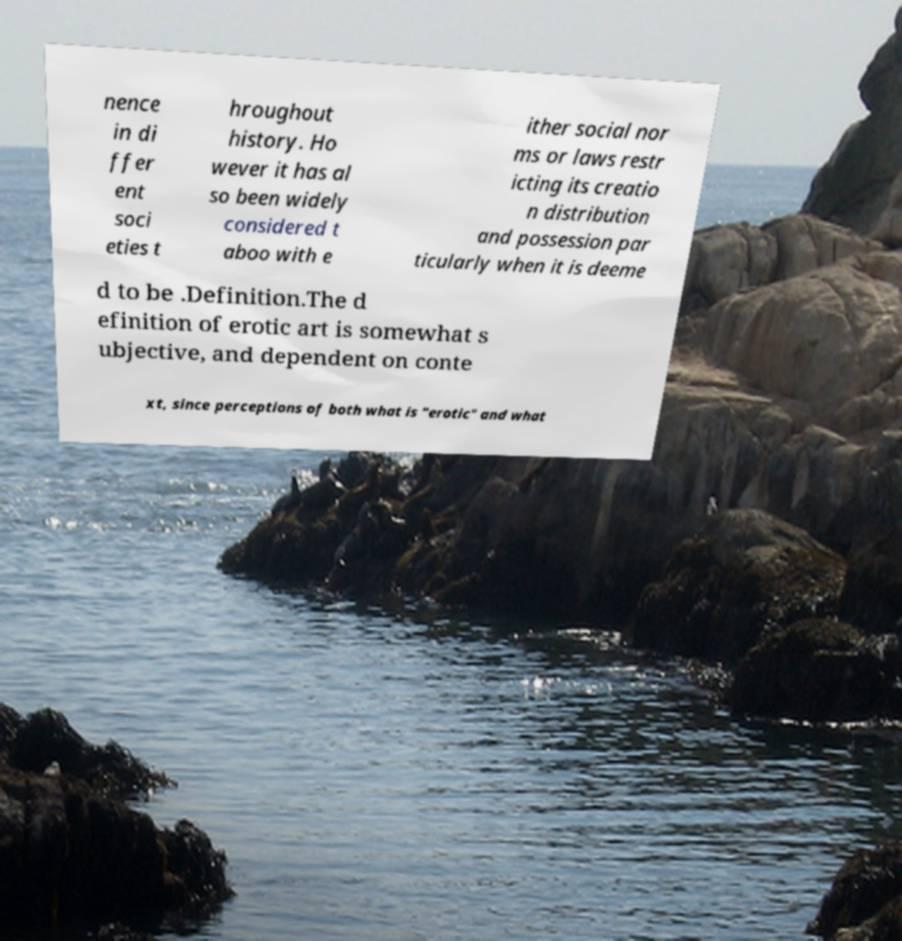Please read and relay the text visible in this image. What does it say? nence in di ffer ent soci eties t hroughout history. Ho wever it has al so been widely considered t aboo with e ither social nor ms or laws restr icting its creatio n distribution and possession par ticularly when it is deeme d to be .Definition.The d efinition of erotic art is somewhat s ubjective, and dependent on conte xt, since perceptions of both what is "erotic" and what 